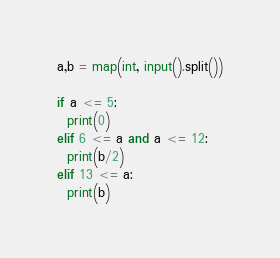<code> <loc_0><loc_0><loc_500><loc_500><_Python_>a,b = map(int, input().split())

if a <= 5:
  print(0)
elif 6 <= a and a <= 12:
  print(b/2)
elif 13 <= a:
  print(b)</code> 